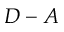Convert formula to latex. <formula><loc_0><loc_0><loc_500><loc_500>D - A</formula> 